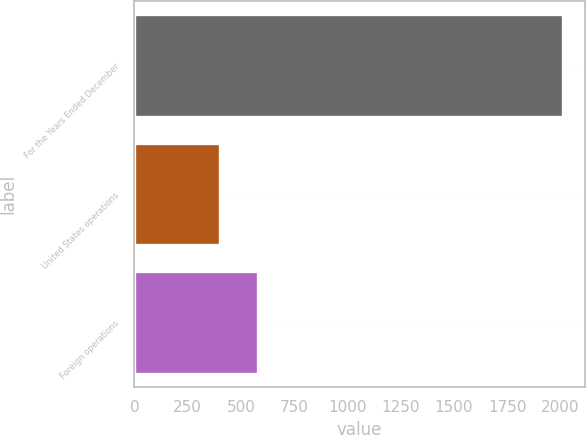Convert chart. <chart><loc_0><loc_0><loc_500><loc_500><bar_chart><fcel>For the Years Ended December<fcel>United States operations<fcel>Foreign operations<nl><fcel>2013<fcel>400.7<fcel>580.4<nl></chart> 